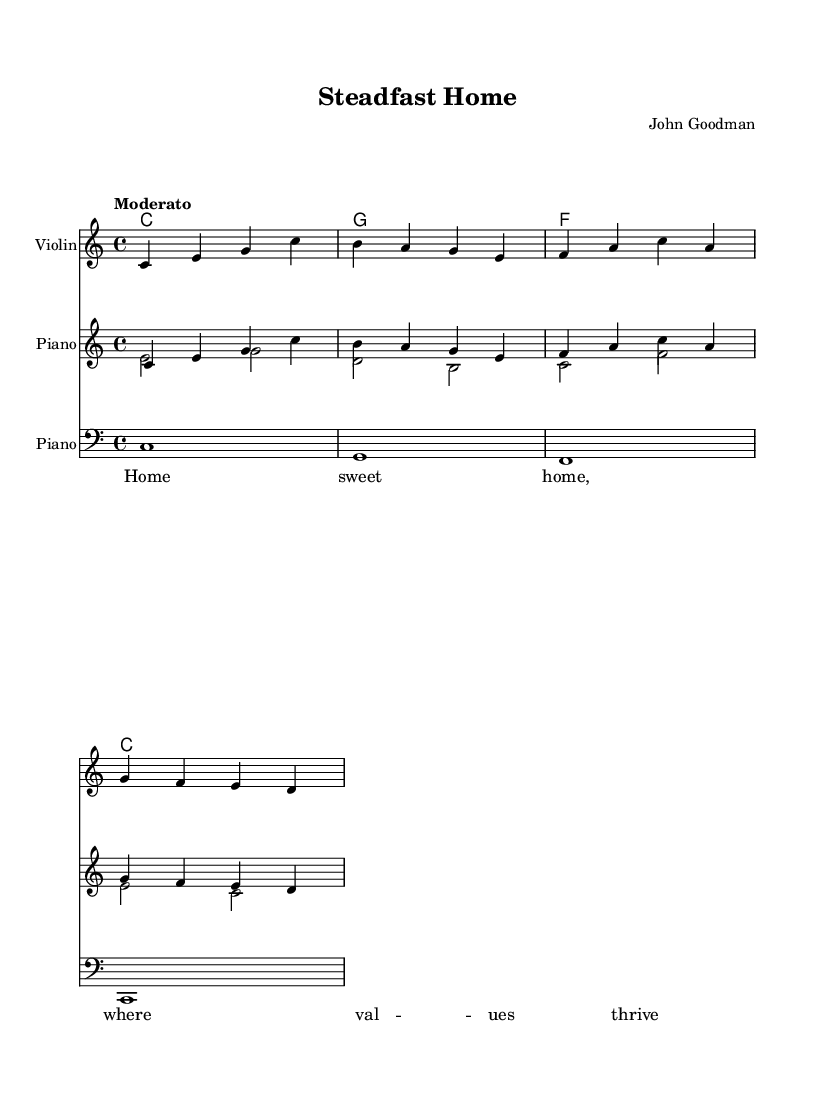What is the key signature of this music? The key signature indicated in the sheet music is C major, which contains no sharps or flats. This can be identified by looking at the key signature section at the beginning of the staff.
Answer: C major What is the time signature of this music? The time signature of the music is 4/4, as shown at the beginning of the score. This means there are four beats in a measure and the quarter note gets one beat.
Answer: 4/4 What is the tempo marking of this piece? The tempo marking in the sheet music is "Moderato," indicating a moderate speed for the performance. This is displayed above the staff and guides the performer on the pace of the music.
Answer: Moderato How many measures are there in the melody section? The melody section contains four measures, as evidenced by the presence of four groups of vertical lines that denote measure separations in the music notation. Counting these gives a total of four.
Answer: 4 What is the first chord in the harmony section? The first chord in the harmony section is C, denoted at the beginning of the chord line. This is identified by the chord's root note and shape, typical in harmonic notation, aligning with the melody.
Answer: C What is the last note of the melody? The last note of the melody is D, which is found at the end of the melody line. This can be determined by looking at the final note placed on the staff.
Answer: D How many instruments are indicated in the score? The score indicates three instruments: Violin, Piano (with treble and bass clefs). This is observed through the separate staffs labeled with each instrument's name at the beginning of the sections.
Answer: 3 